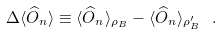<formula> <loc_0><loc_0><loc_500><loc_500>\Delta \langle \widehat { O } _ { n } \rangle \equiv \langle \widehat { O } _ { n } \rangle _ { \rho _ { B } } - \langle \widehat { O } _ { n } \rangle _ { \rho _ { B } ^ { \prime } } \ .</formula> 